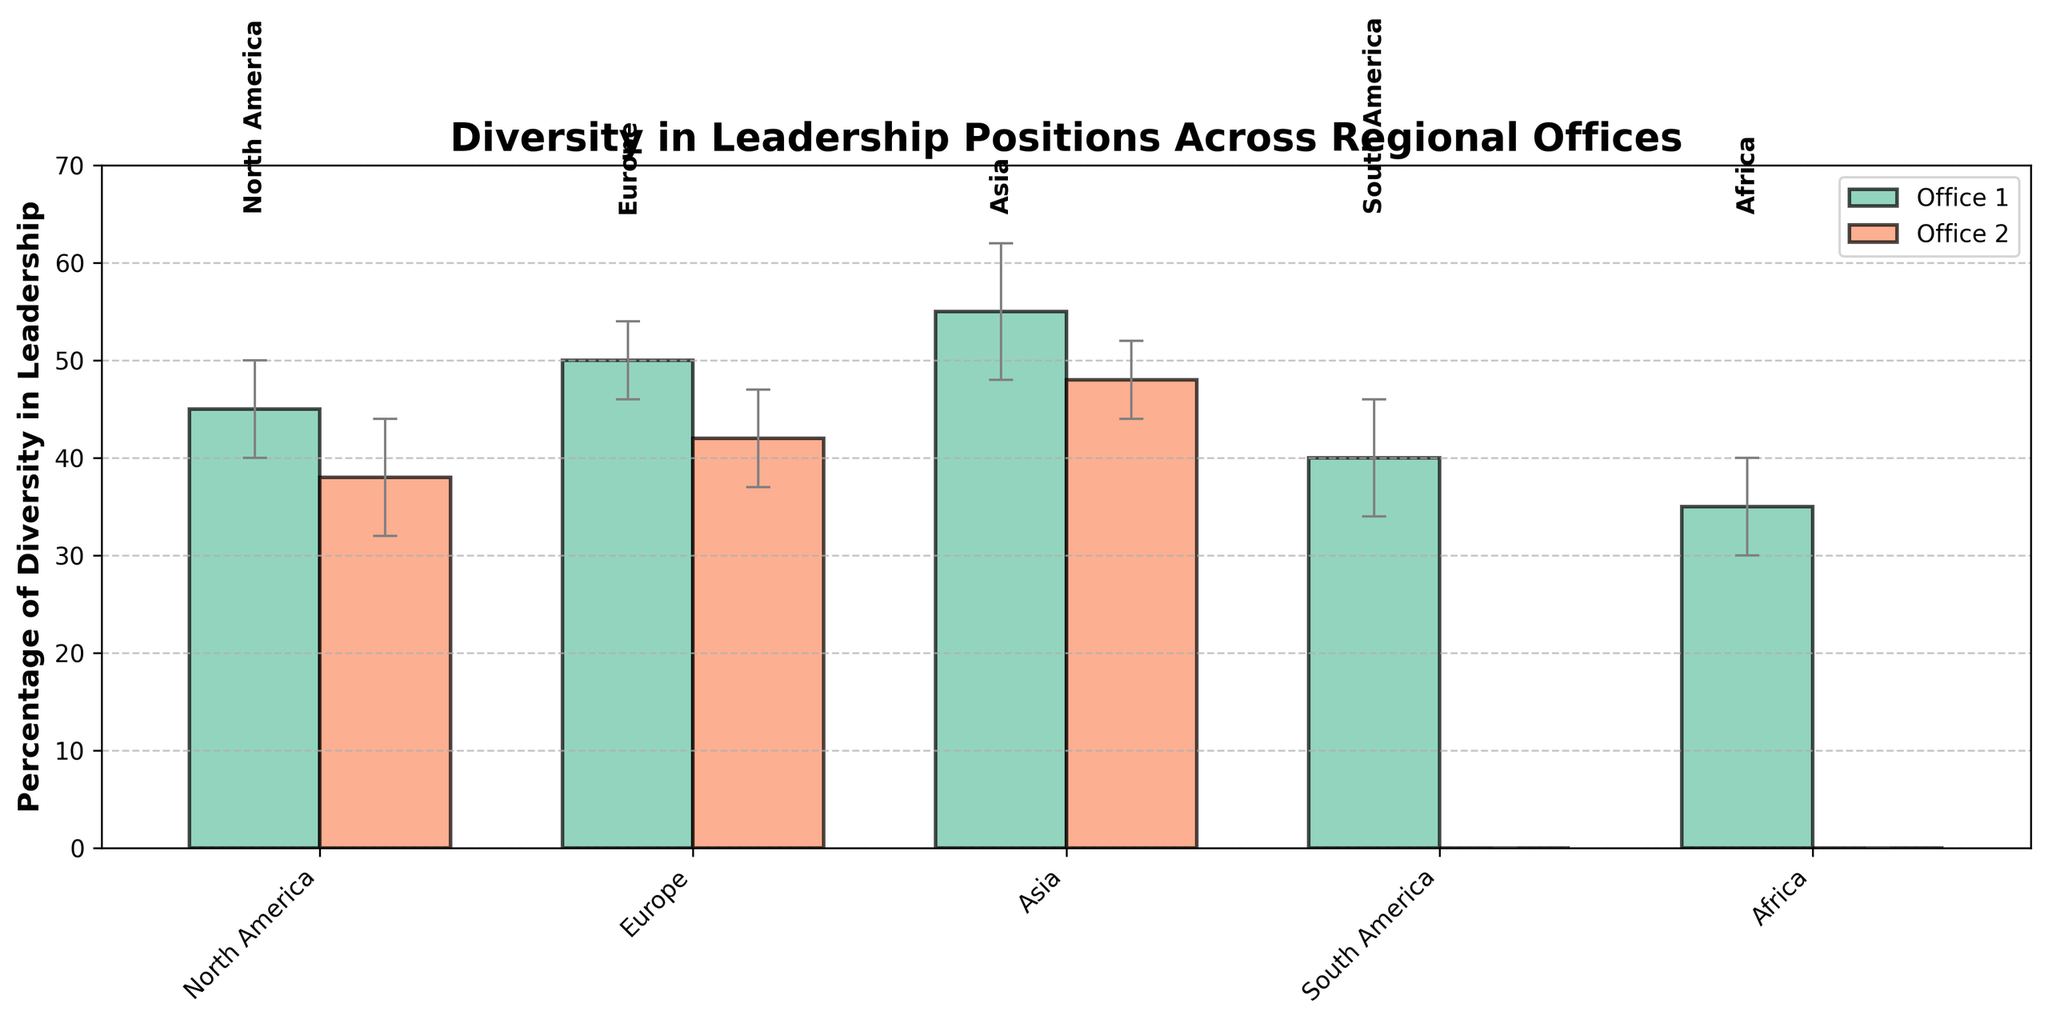Which region has the highest percentage of diversity in leadership positions? By looking at the bar heights, the tallest bar indicates the highest percentage of diversity. In this chart, Tokyo in the Asia region has the tallest bar.
Answer: Tokyo (Asia) What is the title of the chart? The title is typically located at the top center of the chart. In this case, it is clearly written.
Answer: Diversity in Leadership Positions Across Regional Offices What is the range of the y-axis? Looking at the y-axis on the left side of the chart, the range can be seen from the smallest value to the largest marked value.
Answer: 0 to 70 Which office in Europe has the lower percentage of diversity in leadership positions? Europe has two bars: one for London and one for Berlin. By comparing their heights, Berlin has a lower percentage.
Answer: Berlin How many regions are represented in the chart? The x-axis labels correspond to the regions. Counting them gives the total number of regions.
Answer: 5 What are the error bars representing? Error bars indicate the variability or standard deviation of the data points for each location. This is typically shown graphically by the length of the bars extending above and below the mean value.
Answer: Standard Deviation For the North America region, which office has a higher percentage of diversity in leadership? By comparing the two bars for New York and San Francisco, New York has a higher bar, indicating a higher percentage.
Answer: New York What is the average percentage of diversity in leadership positions for the European offices shown? Calculate the average by adding the percentages for London and Berlin and then dividing by the number of offices: (50 + 42) / 2.
Answer: 46 Which region has the least variability in the percentage of diversity in leadership positions? The length of the error bars indicates variability. The shortest error bars correspond to the least variability. In this chart, Singapore in Asia has the shortest error bar.
Answer: Singapore (Asia) Compare the percentage of diversity in leadership positions between Tokyo and Sao Paulo. Is Tokyo's percentage greater? By comparing the heights of the bars for Tokyo and Sao Paulo, it's clear that Tokyo has a higher percentage of diversity.
Answer: Yes 